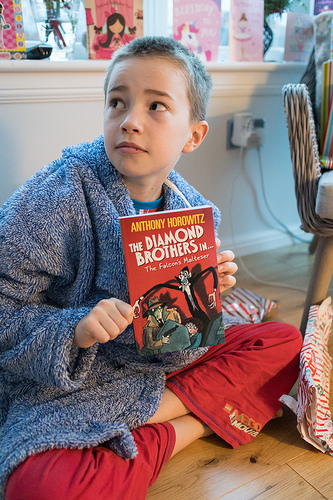<image>
Can you confirm if the wall is in front of the kid? No. The wall is not in front of the kid. The spatial positioning shows a different relationship between these objects. 